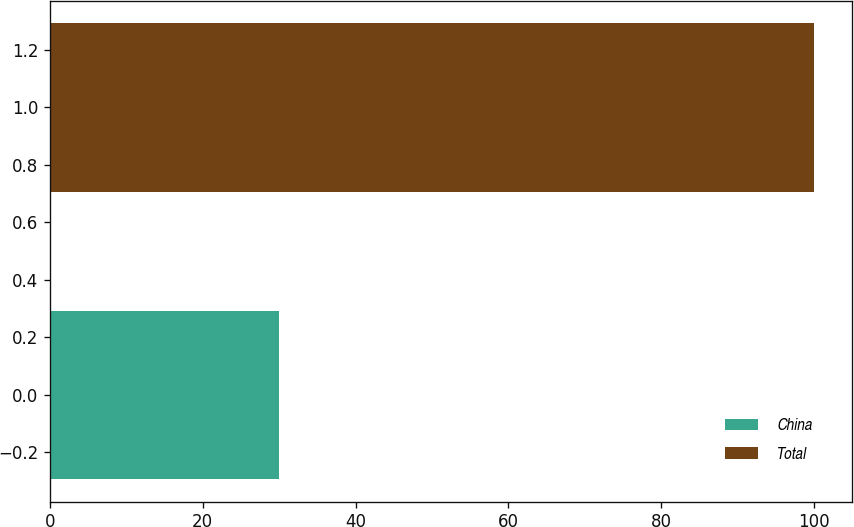Convert chart to OTSL. <chart><loc_0><loc_0><loc_500><loc_500><bar_chart><fcel>China<fcel>Total<nl><fcel>30<fcel>100<nl></chart> 